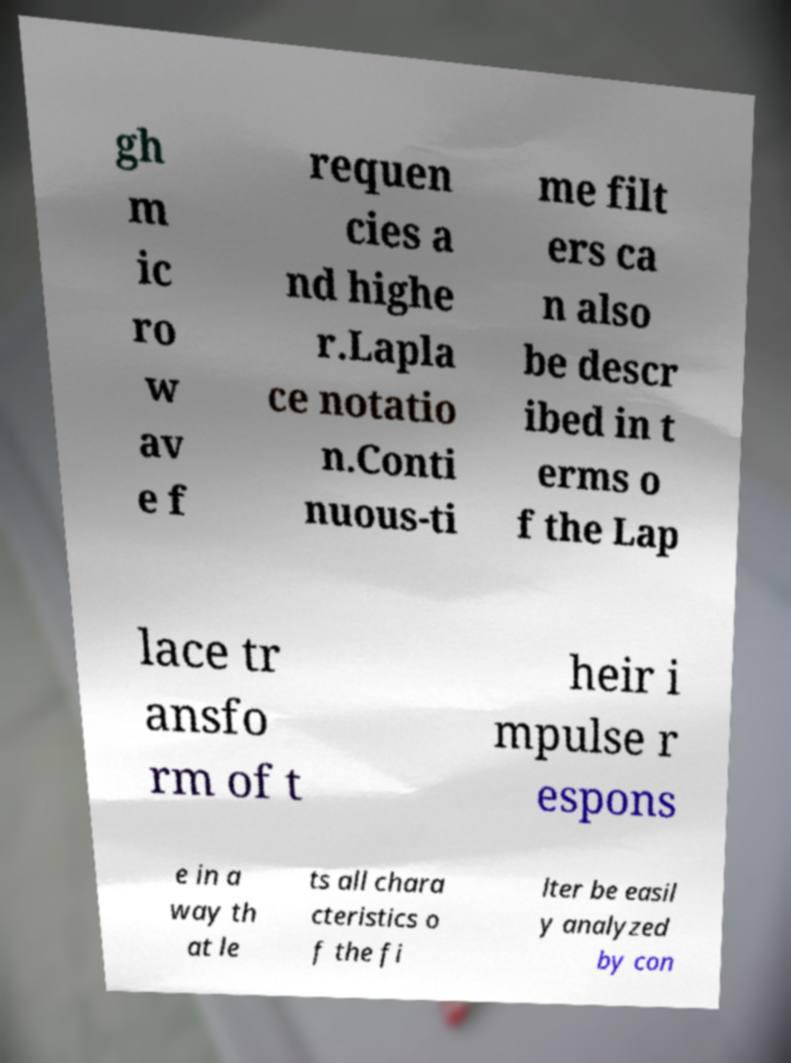Could you extract and type out the text from this image? gh m ic ro w av e f requen cies a nd highe r.Lapla ce notatio n.Conti nuous-ti me filt ers ca n also be descr ibed in t erms o f the Lap lace tr ansfo rm of t heir i mpulse r espons e in a way th at le ts all chara cteristics o f the fi lter be easil y analyzed by con 